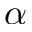<formula> <loc_0><loc_0><loc_500><loc_500>\alpha</formula> 